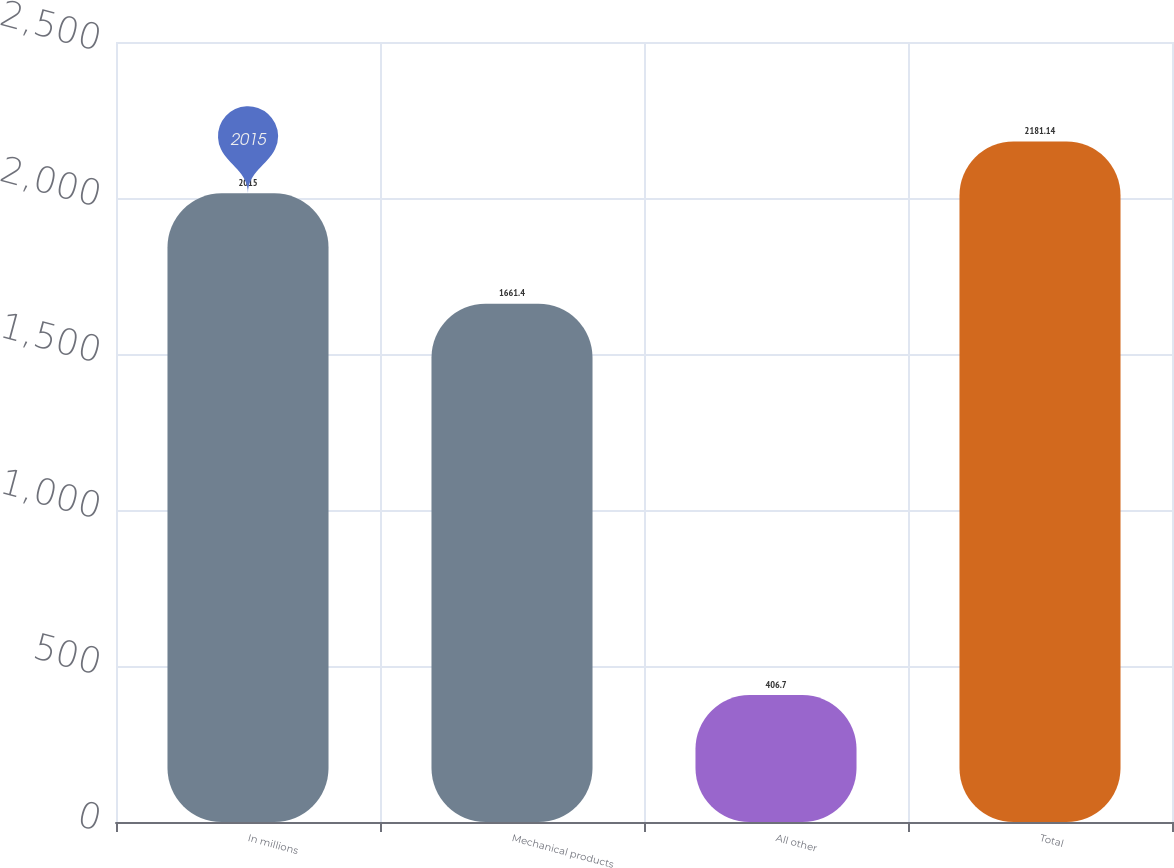Convert chart. <chart><loc_0><loc_0><loc_500><loc_500><bar_chart><fcel>In millions<fcel>Mechanical products<fcel>All other<fcel>Total<nl><fcel>2015<fcel>1661.4<fcel>406.7<fcel>2181.14<nl></chart> 